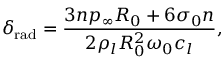Convert formula to latex. <formula><loc_0><loc_0><loc_500><loc_500>\delta _ { r a d } = \frac { 3 n p _ { \infty } R _ { 0 } + 6 \sigma _ { 0 } n } { 2 \rho _ { l } R _ { 0 } ^ { 2 } \omega _ { 0 } c _ { l } } ,</formula> 